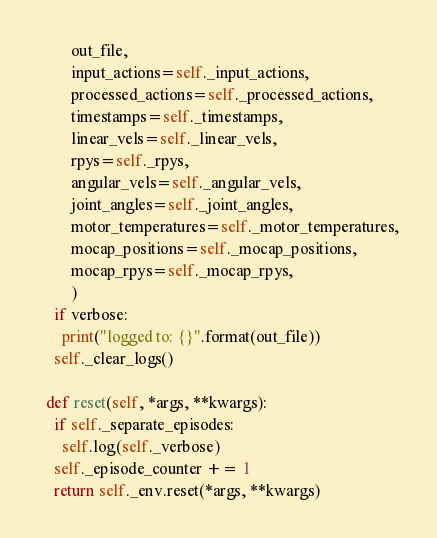Convert code to text. <code><loc_0><loc_0><loc_500><loc_500><_Python_>        out_file,
        input_actions=self._input_actions,
        processed_actions=self._processed_actions,
        timestamps=self._timestamps,
        linear_vels=self._linear_vels,
        rpys=self._rpys,
        angular_vels=self._angular_vels,
        joint_angles=self._joint_angles,
        motor_temperatures=self._motor_temperatures,
        mocap_positions=self._mocap_positions,
        mocap_rpys=self._mocap_rpys,
        )
    if verbose:
      print("logged to: {}".format(out_file))
    self._clear_logs()

  def reset(self, *args, **kwargs):
    if self._separate_episodes:
      self.log(self._verbose)
    self._episode_counter += 1
    return self._env.reset(*args, **kwargs)
</code> 